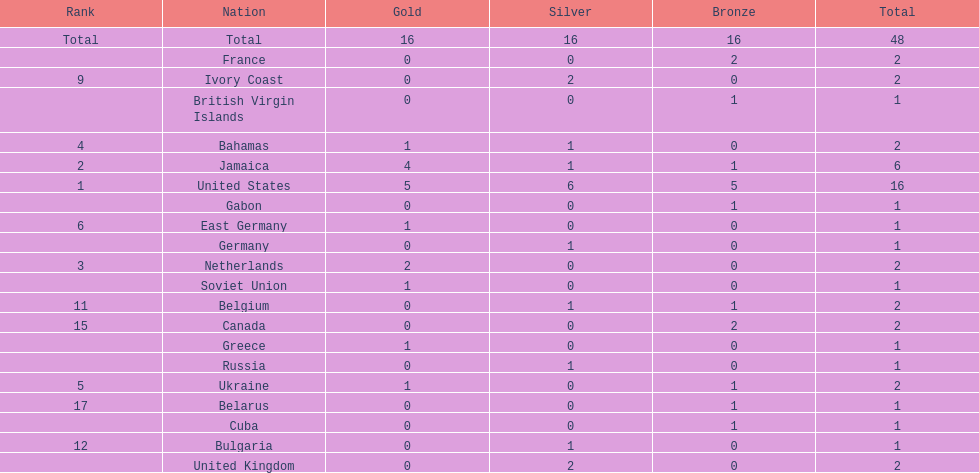How many nations won at least two gold medals? 3. 